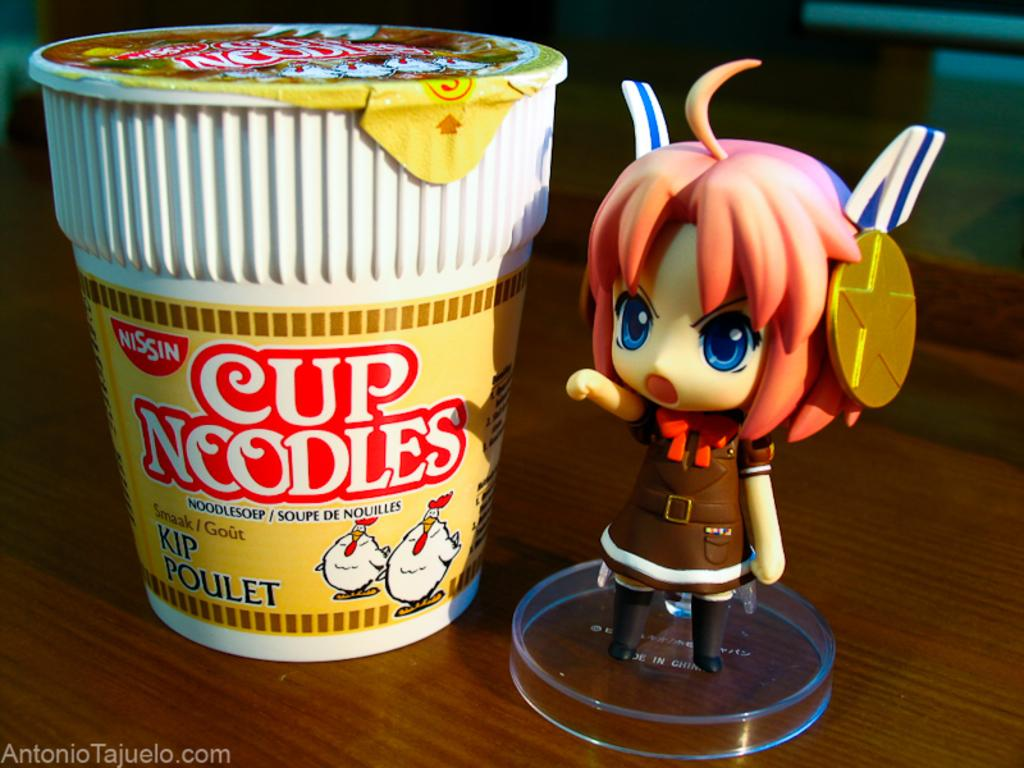What is the main piece of furniture in the image? There is a table in the image. What type of food is on the table? There are cup noodles on the table. What other object is on the table besides the cup noodles? There is a toy on the table. What color is the winter vessel in the image? There is no winter vessel present in the image. 